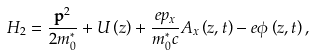Convert formula to latex. <formula><loc_0><loc_0><loc_500><loc_500>H _ { 2 } = \frac { { \mathbf p } ^ { 2 } } { 2 m ^ { * } _ { 0 } } + U \left ( z \right ) + \frac { e p _ { x } } { m ^ { * } _ { 0 } c } A _ { x } \left ( z , t \right ) - e \phi \left ( z , t \right ) ,</formula> 